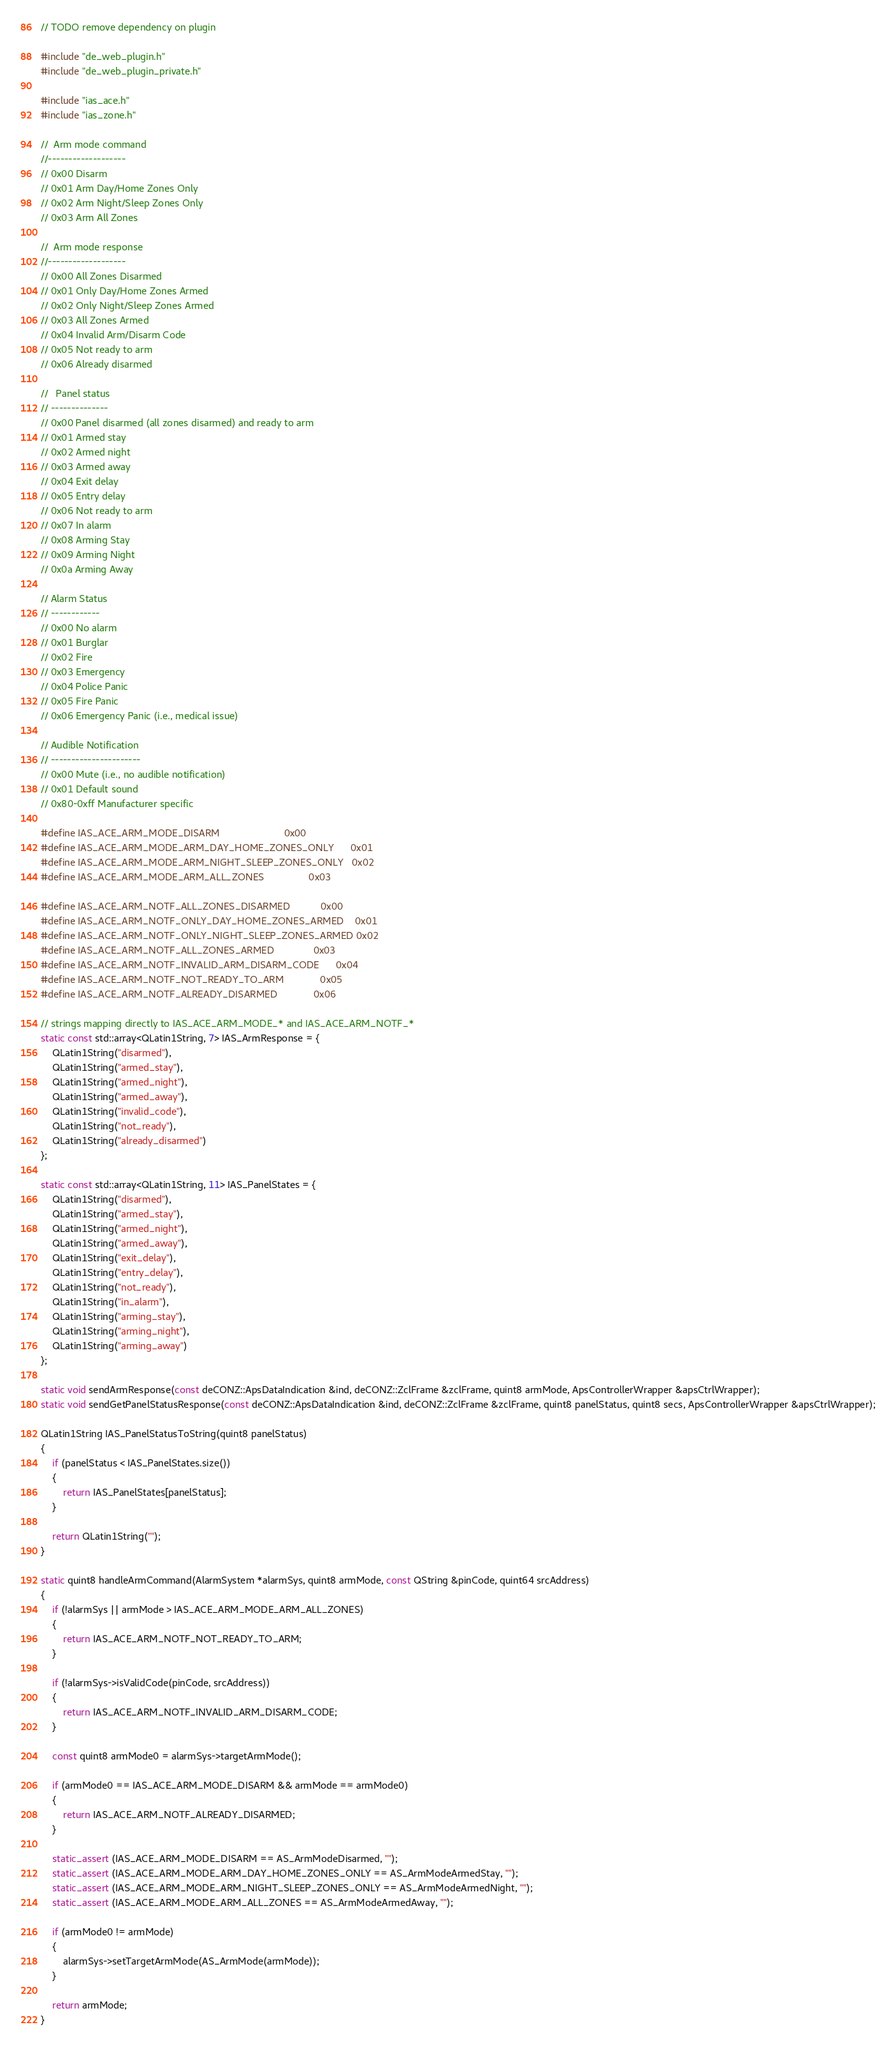Convert code to text. <code><loc_0><loc_0><loc_500><loc_500><_C++_>
// TODO remove dependency on plugin

#include "de_web_plugin.h"
#include "de_web_plugin_private.h"

#include "ias_ace.h"
#include "ias_zone.h"

//  Arm mode command
//-------------------
// 0x00 Disarm    
// 0x01 Arm Day/Home Zones Only
// 0x02 Arm Night/Sleep Zones Only
// 0x03 Arm All Zones

//  Arm mode response
//-------------------
// 0x00 All Zones Disarmed
// 0x01 Only Day/Home Zones Armed
// 0x02 Only Night/Sleep Zones Armed
// 0x03 All Zones Armed
// 0x04 Invalid Arm/Disarm Code
// 0x05 Not ready to arm
// 0x06 Already disarmed

//   Panel status
// --------------        
// 0x00 Panel disarmed (all zones disarmed) and ready to arm
// 0x01 Armed stay
// 0x02 Armed night
// 0x03 Armed away
// 0x04 Exit delay
// 0x05 Entry delay
// 0x06 Not ready to arm
// 0x07 In alarm
// 0x08 Arming Stay
// 0x09 Arming Night
// 0x0a Arming Away

// Alarm Status
// ------------
// 0x00 No alarm
// 0x01 Burglar
// 0x02 Fire
// 0x03 Emergency
// 0x04 Police Panic
// 0x05 Fire Panic
// 0x06 Emergency Panic (i.e., medical issue)

// Audible Notification
// ----------------------   
// 0x00 Mute (i.e., no audible notification)
// 0x01 Default sound
// 0x80-0xff Manufacturer specific

#define IAS_ACE_ARM_MODE_DISARM                       0x00
#define IAS_ACE_ARM_MODE_ARM_DAY_HOME_ZONES_ONLY      0x01
#define IAS_ACE_ARM_MODE_ARM_NIGHT_SLEEP_ZONES_ONLY   0x02
#define IAS_ACE_ARM_MODE_ARM_ALL_ZONES                0x03

#define IAS_ACE_ARM_NOTF_ALL_ZONES_DISARMED           0x00
#define IAS_ACE_ARM_NOTF_ONLY_DAY_HOME_ZONES_ARMED    0x01
#define IAS_ACE_ARM_NOTF_ONLY_NIGHT_SLEEP_ZONES_ARMED 0x02
#define IAS_ACE_ARM_NOTF_ALL_ZONES_ARMED              0x03
#define IAS_ACE_ARM_NOTF_INVALID_ARM_DISARM_CODE      0x04
#define IAS_ACE_ARM_NOTF_NOT_READY_TO_ARM             0x05
#define IAS_ACE_ARM_NOTF_ALREADY_DISARMED             0x06

// strings mapping directly to IAS_ACE_ARM_MODE_* and IAS_ACE_ARM_NOTF_*
static const std::array<QLatin1String, 7> IAS_ArmResponse = {
    QLatin1String("disarmed"),
    QLatin1String("armed_stay"),
    QLatin1String("armed_night"),
    QLatin1String("armed_away"),
    QLatin1String("invalid_code"),
    QLatin1String("not_ready"),
    QLatin1String("already_disarmed")
};

static const std::array<QLatin1String, 11> IAS_PanelStates = {
    QLatin1String("disarmed"),
    QLatin1String("armed_stay"),
    QLatin1String("armed_night"),
    QLatin1String("armed_away"),
    QLatin1String("exit_delay"),
    QLatin1String("entry_delay"),
    QLatin1String("not_ready"),
    QLatin1String("in_alarm"),
    QLatin1String("arming_stay"),
    QLatin1String("arming_night"),
    QLatin1String("arming_away")
};

static void sendArmResponse(const deCONZ::ApsDataIndication &ind, deCONZ::ZclFrame &zclFrame, quint8 armMode, ApsControllerWrapper &apsCtrlWrapper);
static void sendGetPanelStatusResponse(const deCONZ::ApsDataIndication &ind, deCONZ::ZclFrame &zclFrame, quint8 panelStatus, quint8 secs, ApsControllerWrapper &apsCtrlWrapper);

QLatin1String IAS_PanelStatusToString(quint8 panelStatus)
{
    if (panelStatus < IAS_PanelStates.size())
    {
        return IAS_PanelStates[panelStatus];
    }

    return QLatin1String("");
}

static quint8 handleArmCommand(AlarmSystem *alarmSys, quint8 armMode, const QString &pinCode, quint64 srcAddress)
{
    if (!alarmSys || armMode > IAS_ACE_ARM_MODE_ARM_ALL_ZONES)
    {
        return IAS_ACE_ARM_NOTF_NOT_READY_TO_ARM;
    }

    if (!alarmSys->isValidCode(pinCode, srcAddress))
    {
        return IAS_ACE_ARM_NOTF_INVALID_ARM_DISARM_CODE;
    }

    const quint8 armMode0 = alarmSys->targetArmMode();

    if (armMode0 == IAS_ACE_ARM_MODE_DISARM && armMode == armMode0)
    {
        return IAS_ACE_ARM_NOTF_ALREADY_DISARMED;
    }

    static_assert (IAS_ACE_ARM_MODE_DISARM == AS_ArmModeDisarmed, "");
    static_assert (IAS_ACE_ARM_MODE_ARM_DAY_HOME_ZONES_ONLY == AS_ArmModeArmedStay, "");
    static_assert (IAS_ACE_ARM_MODE_ARM_NIGHT_SLEEP_ZONES_ONLY == AS_ArmModeArmedNight, "");
    static_assert (IAS_ACE_ARM_MODE_ARM_ALL_ZONES == AS_ArmModeArmedAway, "");

    if (armMode0 != armMode)
    {
        alarmSys->setTargetArmMode(AS_ArmMode(armMode));
    }

    return armMode;
}
</code> 